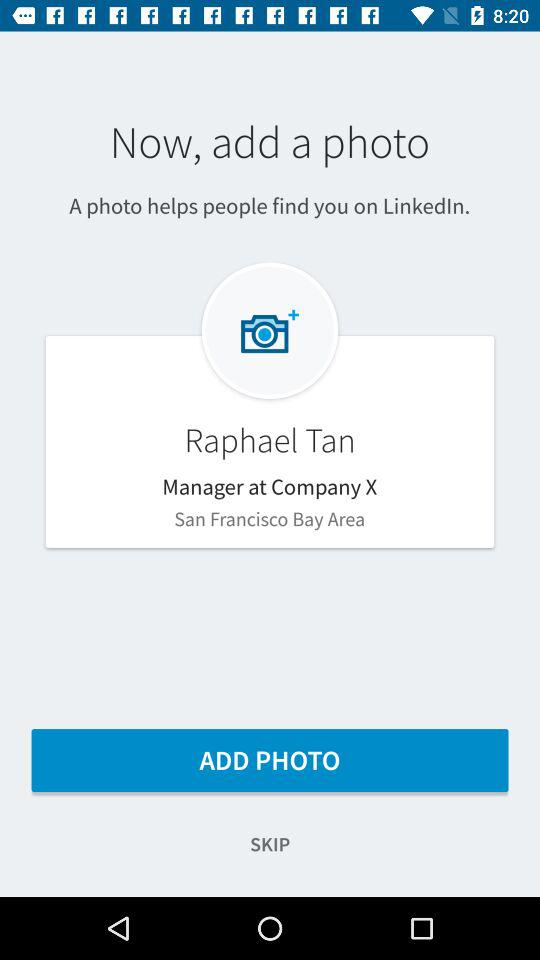What is the name of the company? The name of the company is "Company X". 